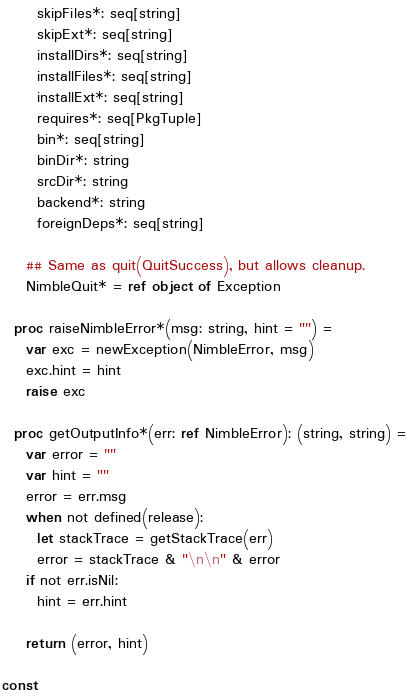Convert code to text. <code><loc_0><loc_0><loc_500><loc_500><_Nim_>      skipFiles*: seq[string]
      skipExt*: seq[string]
      installDirs*: seq[string]
      installFiles*: seq[string]
      installExt*: seq[string]
      requires*: seq[PkgTuple]
      bin*: seq[string]
      binDir*: string
      srcDir*: string
      backend*: string
      foreignDeps*: seq[string]

    ## Same as quit(QuitSuccess), but allows cleanup.
    NimbleQuit* = ref object of Exception

  proc raiseNimbleError*(msg: string, hint = "") =
    var exc = newException(NimbleError, msg)
    exc.hint = hint
    raise exc

  proc getOutputInfo*(err: ref NimbleError): (string, string) =
    var error = ""
    var hint = ""
    error = err.msg
    when not defined(release):
      let stackTrace = getStackTrace(err)
      error = stackTrace & "\n\n" & error
    if not err.isNil:
      hint = err.hint

    return (error, hint)

const</code> 